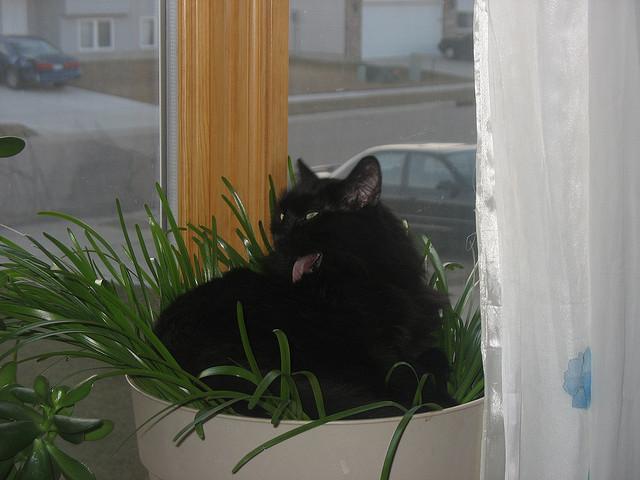Is this a backdoor?
Give a very brief answer. No. Is the cat looking out the window?
Short answer required. No. Are the cats looking for water?
Concise answer only. No. What is in the bowl with the cat?
Be succinct. Plant. Is there grass in the image?
Short answer required. Yes. Does the cat have it's mouth open?
Short answer required. Yes. Is the cat outside?
Be succinct. No. 